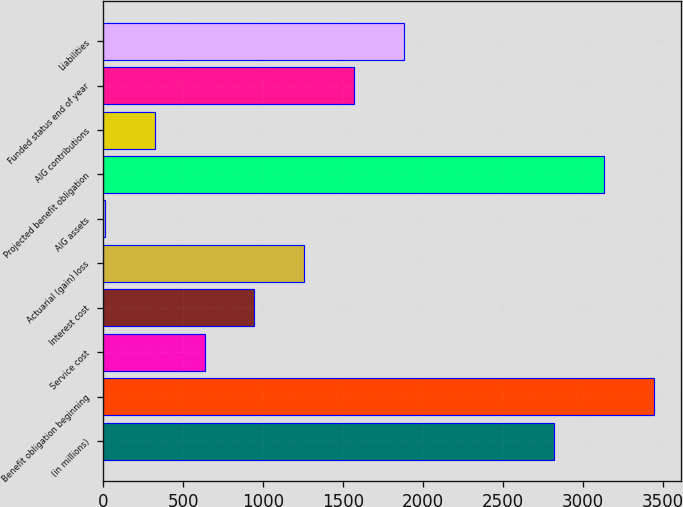Convert chart to OTSL. <chart><loc_0><loc_0><loc_500><loc_500><bar_chart><fcel>(in millions)<fcel>Benefit obligation beginning<fcel>Service cost<fcel>Interest cost<fcel>Actuarial (gain) loss<fcel>AIG assets<fcel>Projected benefit obligation<fcel>AIG contributions<fcel>Funded status end of year<fcel>Liabilities<nl><fcel>2818.9<fcel>3443.1<fcel>634.2<fcel>946.3<fcel>1258.4<fcel>10<fcel>3131<fcel>322.1<fcel>1570.5<fcel>1882.6<nl></chart> 